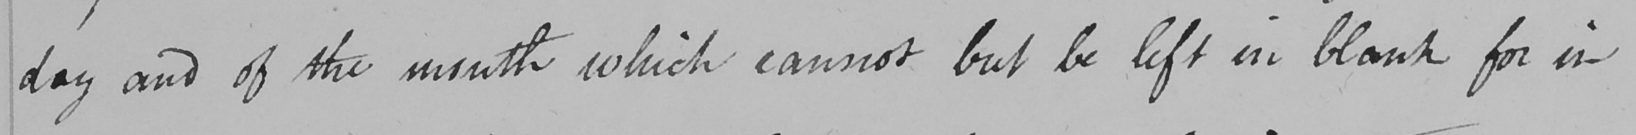What does this handwritten line say? day and of the month which cannot but be left in blank for in 